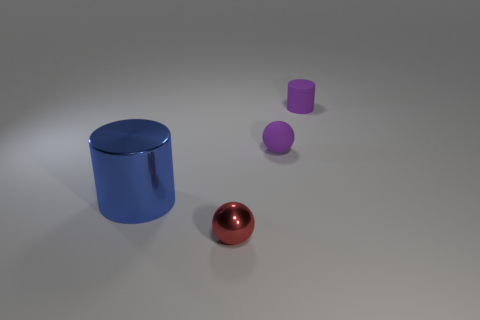Subtract 1 spheres. How many spheres are left? 1 Subtract all yellow spheres. How many gray cylinders are left? 0 Subtract all small spheres. Subtract all large red shiny things. How many objects are left? 2 Add 3 rubber balls. How many rubber balls are left? 4 Add 2 rubber cylinders. How many rubber cylinders exist? 3 Add 3 blue shiny objects. How many objects exist? 7 Subtract 1 blue cylinders. How many objects are left? 3 Subtract all brown balls. Subtract all yellow cylinders. How many balls are left? 2 